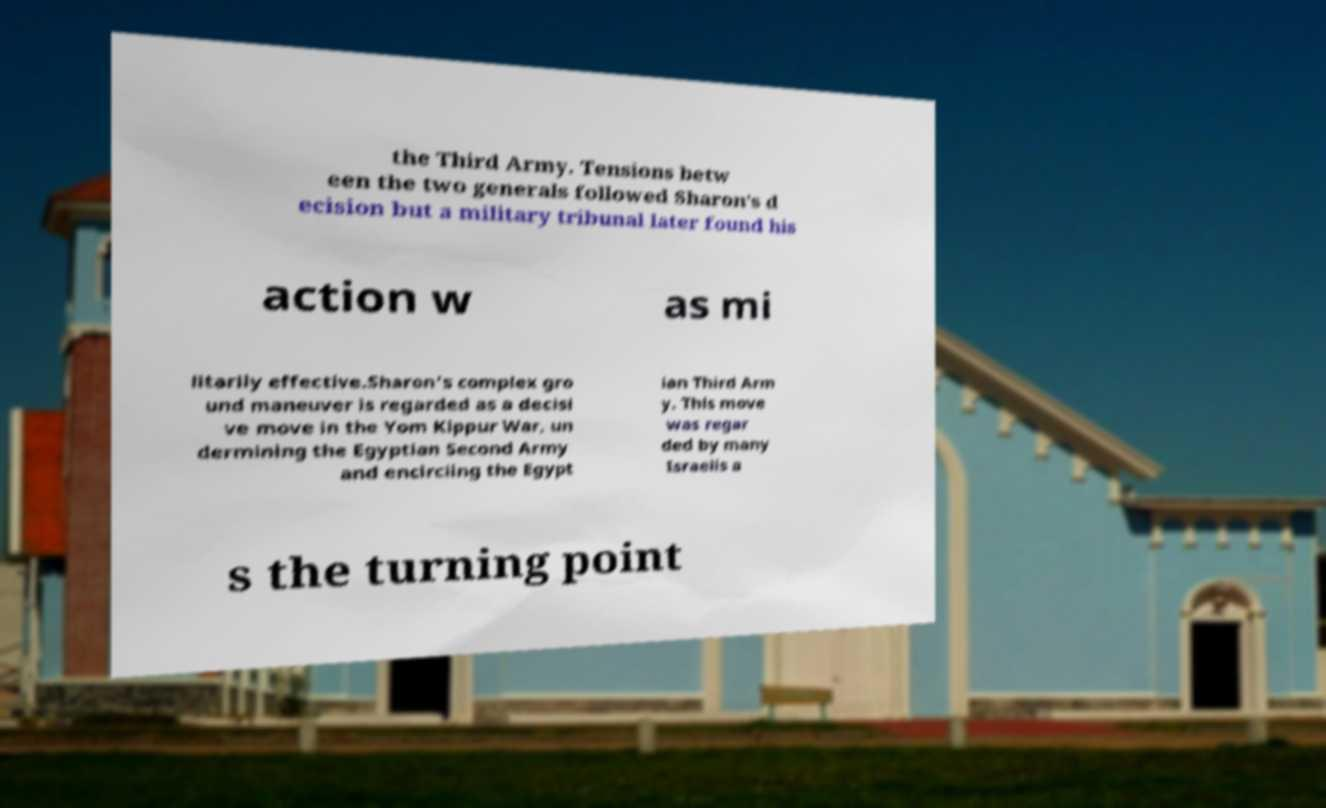What messages or text are displayed in this image? I need them in a readable, typed format. the Third Army. Tensions betw een the two generals followed Sharon's d ecision but a military tribunal later found his action w as mi litarily effective.Sharon's complex gro und maneuver is regarded as a decisi ve move in the Yom Kippur War, un dermining the Egyptian Second Army and encircling the Egypt ian Third Arm y. This move was regar ded by many Israelis a s the turning point 